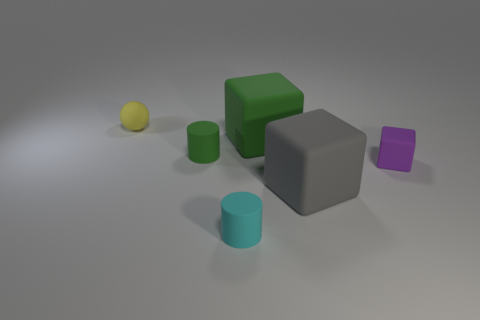Can you describe the layout of all the objects? Certainly! The image shows a collection of geometric shapes on a flat surface. There is a small yellow sphere to the far left. Right of the sphere is a small green cylinder, and to the right of that is a larger matte grey cube. Next to the cube, on its right, there is a smaller grey cube. In line with the green cylinder and the large cube, there is a small matte teal cylinder, and to its right, slightly behind the small grey cube, is a matte purple cube. 